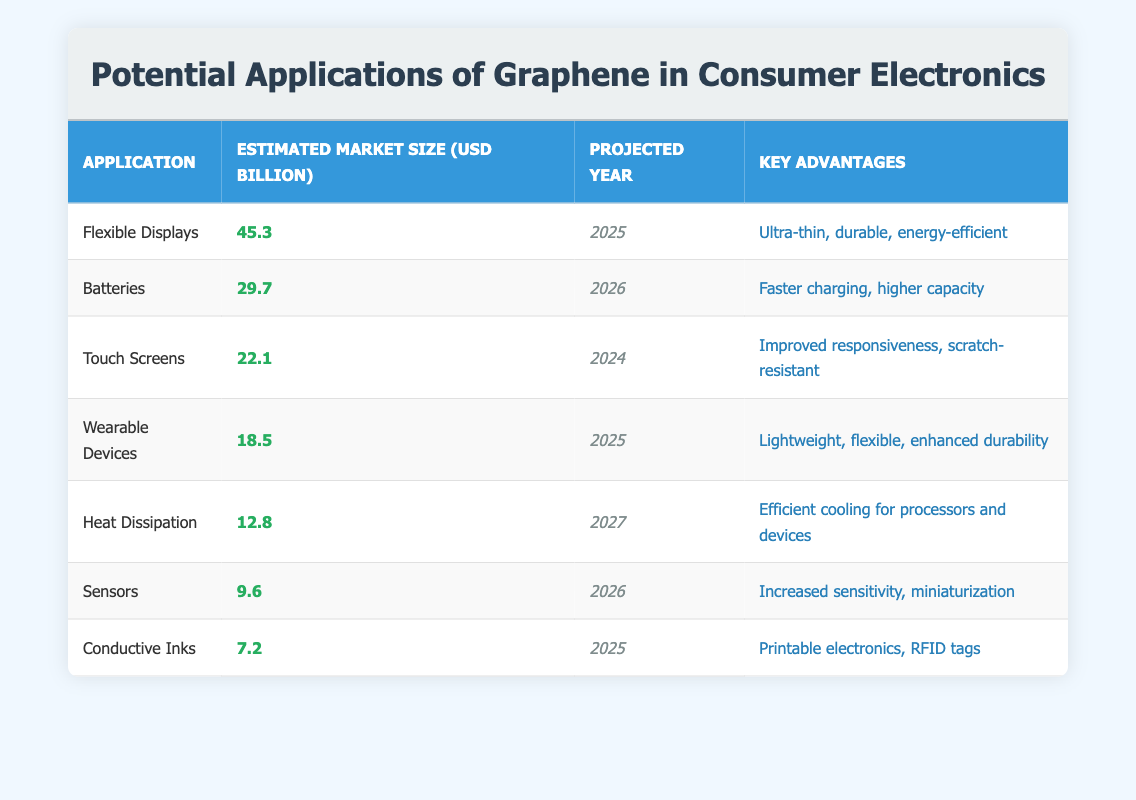What is the estimated market size for flexible displays? From the table, the estimated market size for flexible displays is listed under the respective column, which shows 45.3 billion USD.
Answer: 45.3 In what year is the market size for batteries projected to reach 29.7 billion USD? Looking at the table, the projected year next to the market size of 29.7 billion USD for batteries is 2026.
Answer: 2026 Which application has the lowest estimated market size? By examining the estimated market sizes in the table, conductive inks show the lowest value of 7.2 billion USD.
Answer: Conductive Inks Is the estimated market size for sensors greater than 10 billion USD? When checking the value for sensors in the table, it shows 9.6 billion USD, which is less than 10 billion USD. Therefore, the answer is no.
Answer: No What is the combined estimated market size of wearable devices and heat dissipation applications? The estimated market size for wearable devices is 18.5 billion USD and for heat dissipation, it is 12.8 billion USD. Adding these together gives us (18.5 + 12.8) = 31.3 billion USD.
Answer: 31.3 Which application is projected to have a market size of 22.1 billion USD? The table lists touch screens with a projected market size of 22.1 billion USD, specifically indicating that it's projected to be achieved by the year 2024.
Answer: Touch Screens Are the key advantages of batteries related to charging speed? The key advantages listed for batteries in the table include "faster charging" and "higher capacity," confirming that charging speed is indeed mentioned.
Answer: Yes What is the average estimated market size for the applications listed in the table? To find the average, sum all the estimated market sizes: 45.3 + 29.7 + 22.1 + 18.5 + 12.8 + 9.6 + 7.2 = 145.2 billion USD. Dividing this by the number of applications (7) gives an average of 145.2/7 = 20.74 billion USD.
Answer: 20.74 Which application is expected to have the earliest estimated market size projection? Upon reviewing the projected years, touch screens are projected for the year 2024, which is the earliest compared to other applications.
Answer: Touch Screens 